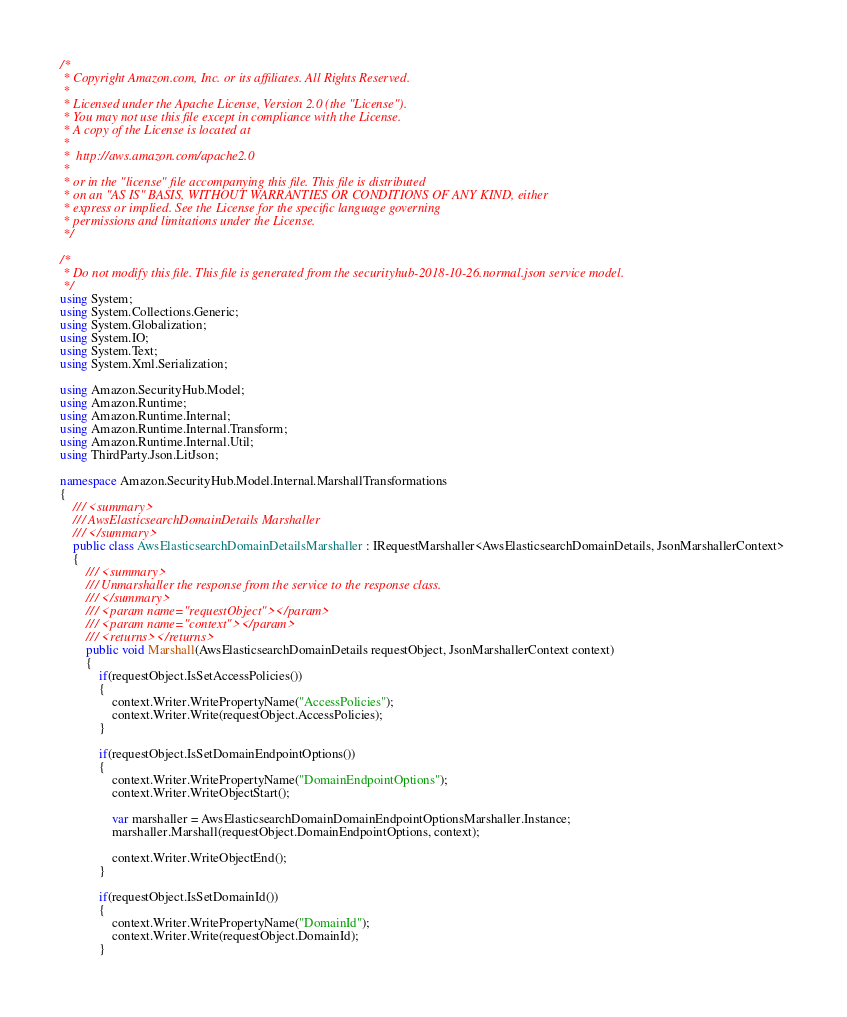<code> <loc_0><loc_0><loc_500><loc_500><_C#_>/*
 * Copyright Amazon.com, Inc. or its affiliates. All Rights Reserved.
 * 
 * Licensed under the Apache License, Version 2.0 (the "License").
 * You may not use this file except in compliance with the License.
 * A copy of the License is located at
 * 
 *  http://aws.amazon.com/apache2.0
 * 
 * or in the "license" file accompanying this file. This file is distributed
 * on an "AS IS" BASIS, WITHOUT WARRANTIES OR CONDITIONS OF ANY KIND, either
 * express or implied. See the License for the specific language governing
 * permissions and limitations under the License.
 */

/*
 * Do not modify this file. This file is generated from the securityhub-2018-10-26.normal.json service model.
 */
using System;
using System.Collections.Generic;
using System.Globalization;
using System.IO;
using System.Text;
using System.Xml.Serialization;

using Amazon.SecurityHub.Model;
using Amazon.Runtime;
using Amazon.Runtime.Internal;
using Amazon.Runtime.Internal.Transform;
using Amazon.Runtime.Internal.Util;
using ThirdParty.Json.LitJson;

namespace Amazon.SecurityHub.Model.Internal.MarshallTransformations
{
    /// <summary>
    /// AwsElasticsearchDomainDetails Marshaller
    /// </summary>       
    public class AwsElasticsearchDomainDetailsMarshaller : IRequestMarshaller<AwsElasticsearchDomainDetails, JsonMarshallerContext> 
    {
        /// <summary>
        /// Unmarshaller the response from the service to the response class.
        /// </summary>  
        /// <param name="requestObject"></param>
        /// <param name="context"></param>
        /// <returns></returns>
        public void Marshall(AwsElasticsearchDomainDetails requestObject, JsonMarshallerContext context)
        {
            if(requestObject.IsSetAccessPolicies())
            {
                context.Writer.WritePropertyName("AccessPolicies");
                context.Writer.Write(requestObject.AccessPolicies);
            }

            if(requestObject.IsSetDomainEndpointOptions())
            {
                context.Writer.WritePropertyName("DomainEndpointOptions");
                context.Writer.WriteObjectStart();

                var marshaller = AwsElasticsearchDomainDomainEndpointOptionsMarshaller.Instance;
                marshaller.Marshall(requestObject.DomainEndpointOptions, context);

                context.Writer.WriteObjectEnd();
            }

            if(requestObject.IsSetDomainId())
            {
                context.Writer.WritePropertyName("DomainId");
                context.Writer.Write(requestObject.DomainId);
            }
</code> 